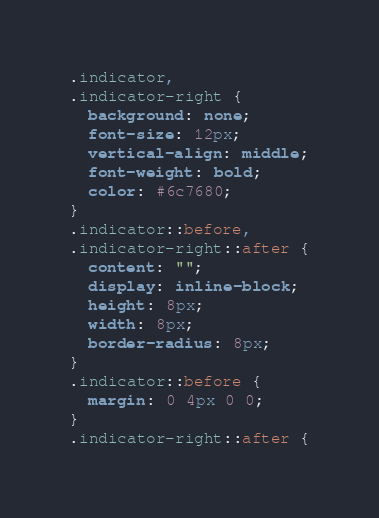Convert code to text. <code><loc_0><loc_0><loc_500><loc_500><_CSS_>.indicator,
.indicator-right {
  background: none;
  font-size: 12px;
  vertical-align: middle;
  font-weight: bold;
  color: #6c7680;
}
.indicator::before,
.indicator-right::after {
  content: "";
  display: inline-block;
  height: 8px;
  width: 8px;
  border-radius: 8px;
}
.indicator::before {
  margin: 0 4px 0 0;
}
.indicator-right::after {</code> 